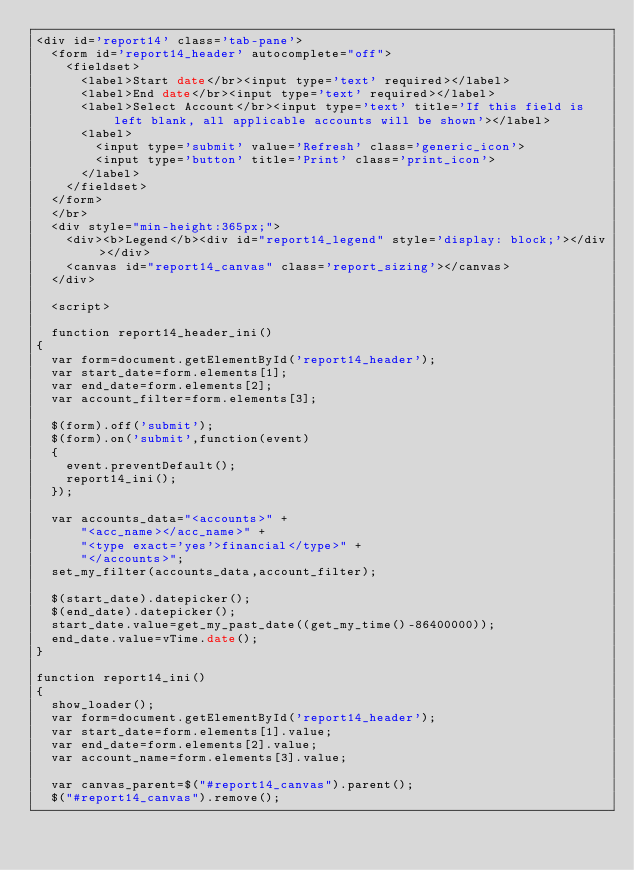Convert code to text. <code><loc_0><loc_0><loc_500><loc_500><_PHP_><div id='report14' class='tab-pane'>
	<form id='report14_header' autocomplete="off">
		<fieldset>
			<label>Start date</br><input type='text' required></label>
			<label>End date</br><input type='text' required></label>
			<label>Select Account</br><input type='text' title='If this field is left blank, all applicable accounts will be shown'></label>
			<label>
				<input type='submit' value='Refresh' class='generic_icon'>
				<input type='button' title='Print' class='print_icon'>
			</label>	
		</fieldset>
	</form>
	</br>
	<div style="min-height:365px;">
		<div><b>Legend</b><div id="report14_legend" style='display: block;'></div></div>
		<canvas id="report14_canvas" class='report_sizing'></canvas>
	</div>
	
	<script>
	
	function report14_header_ini()
{	
	var form=document.getElementById('report14_header');
	var start_date=form.elements[1];
	var end_date=form.elements[2];
	var account_filter=form.elements[3];

	$(form).off('submit');
	$(form).on('submit',function(event)
	{
		event.preventDefault();
		report14_ini();
	});

	var accounts_data="<accounts>" +
			"<acc_name></acc_name>" +
			"<type exact='yes'>financial</type>" +
			"</accounts>";
	set_my_filter(accounts_data,account_filter);
	
	$(start_date).datepicker();
	$(end_date).datepicker();
	start_date.value=get_my_past_date((get_my_time()-86400000));
	end_date.value=vTime.date();
}

function report14_ini()
{
	show_loader();
	var form=document.getElementById('report14_header');
	var start_date=form.elements[1].value;
	var end_date=form.elements[2].value;
	var account_name=form.elements[3].value;
	
	var canvas_parent=$("#report14_canvas").parent();
	$("#report14_canvas").remove();</code> 